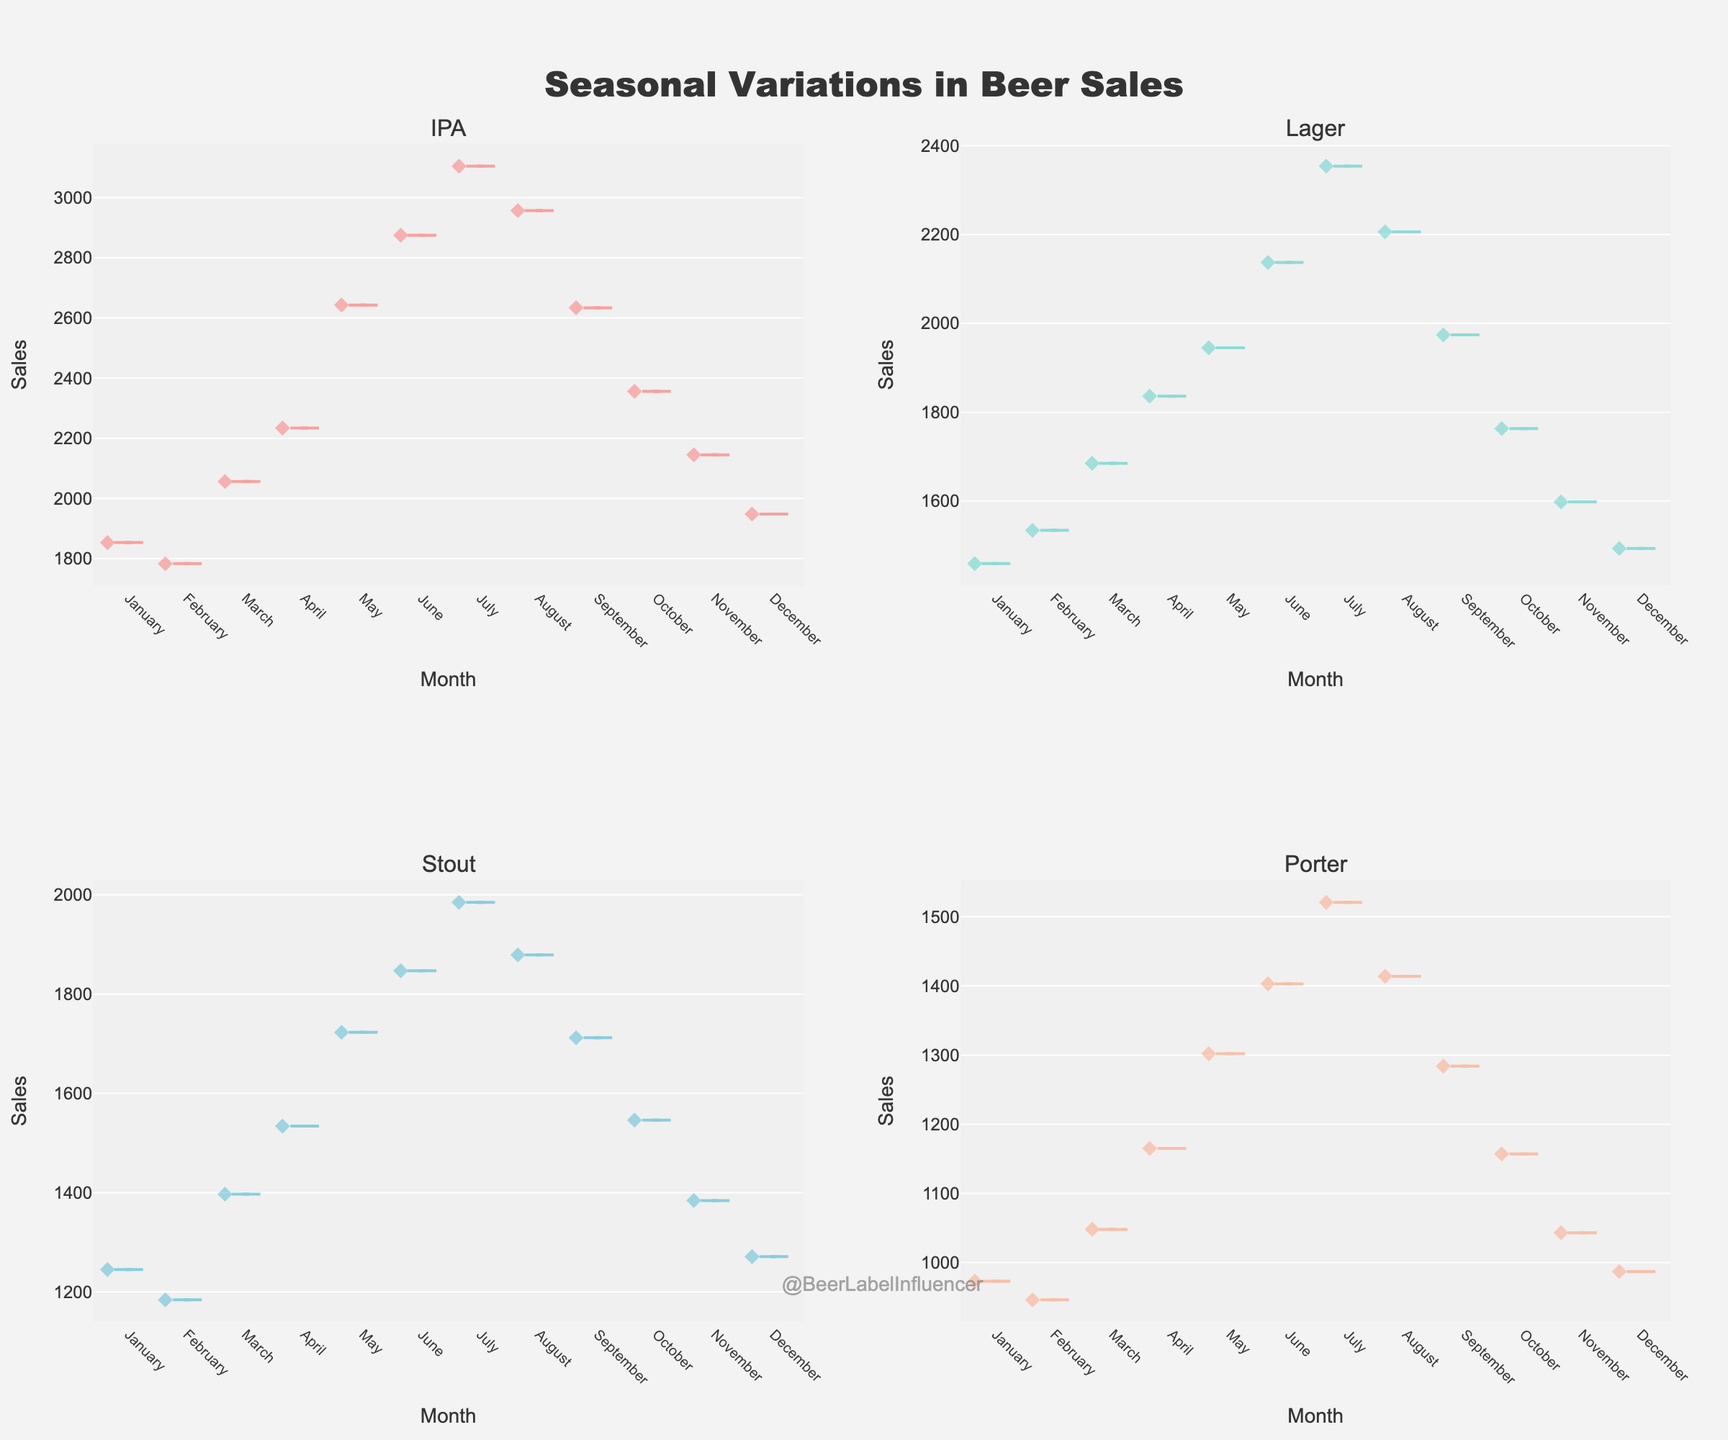What is the highest sales month for IPA? Looking at the plot for the IPA, the highest point of the violin represents the highest sales. This highest point is in July.
Answer: July Which beer category has the smallest difference in sales between the highest and lowest months? To find the category with the smallest sales difference, observe the range of the violins (from highest to lowest points) for each category. Porter has the smallest range compared to IPA, Lager, and Stout.
Answer: Porter In which month does Lager see its peak sales? Look at the plot for Lager and identify the month corresponding to the highest point of the violin. This peak is in July.
Answer: July What is the average peak sales for all beer categories in July? Extract peak sales values for each category in July: IPA (3105), Lager (2354), Stout (1985), and Porter (1521). Sum these values and divide by four to get the average. (3105 + 2354 + 1985 + 1521) / 4 = 2241.25
Answer: 2241.25 Which months have sales below 1500 for Porter? Observe the Porter plot and identify months where the bottom edge of the box or the lower section of the violin density falls below 1500. These months are January, February, December, October, and November.
Answer: January, February, December, October, November What is the general trend of sales for IPA from January to December? From January to July, IPA sales generally increase, peak in July, and then decrease from August to December.
Answer: Increase, peak in July, then decrease Which month exhibits the most variation in sales for Stout? Look at the width of the violin plot for Stout; the widest violin represents the most variation in sales. The widest segment appears in July.
Answer: July How do sales trends of Lager compare between August and September? Compare the height and shape of the Lager violins for August and September. August sales are slightly higher and decrease in September.
Answer: Higher in August, lower in September 